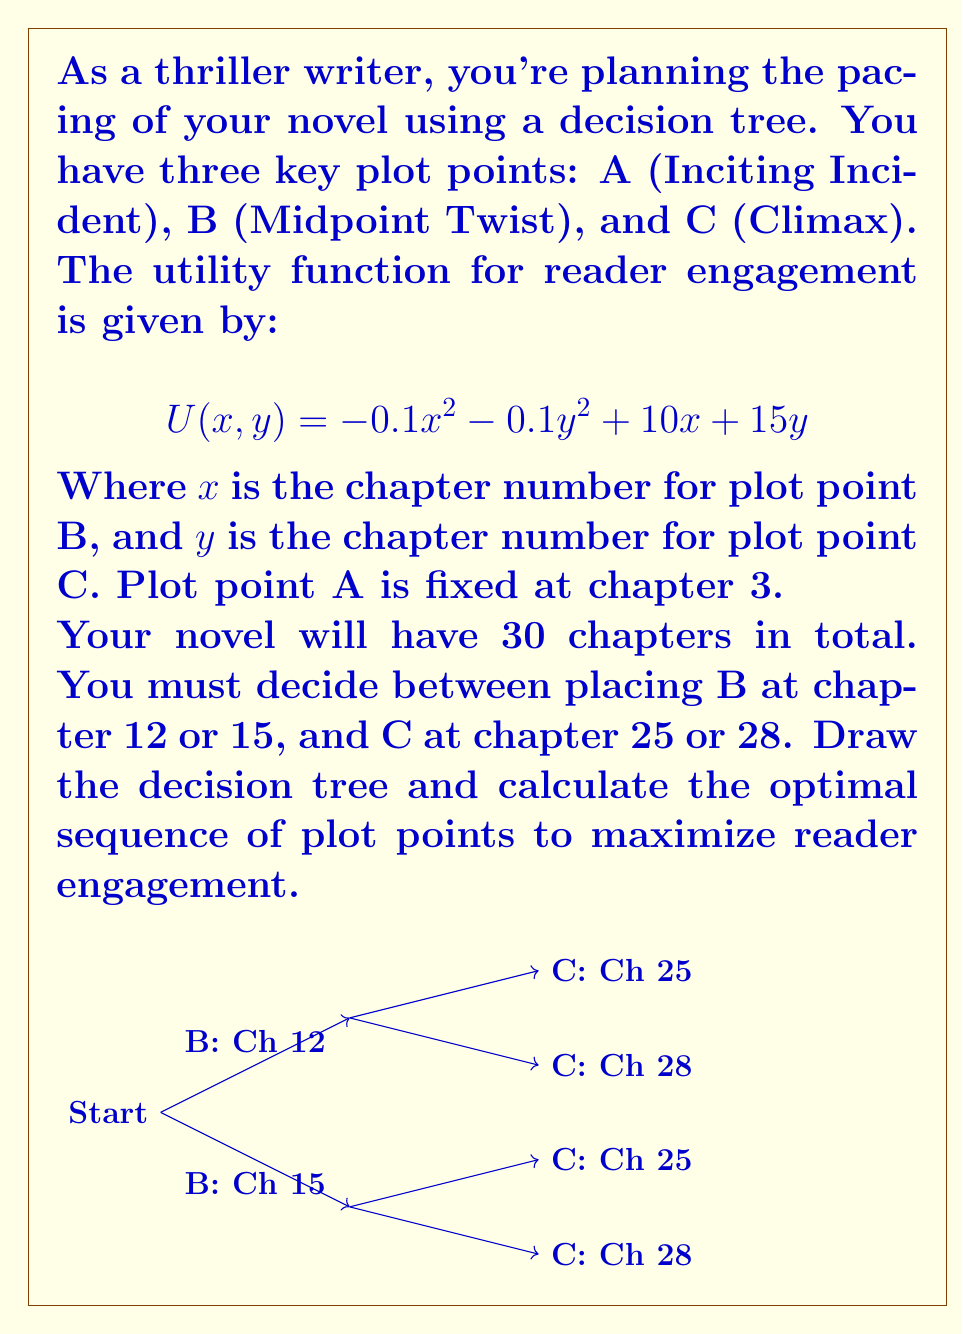What is the answer to this math problem? Let's approach this step-by-step:

1) We need to calculate the utility for each combination of B and C:

   a) B at 12, C at 25: 
      $$U(12, 25) = -0.1(12^2) - 0.1(25^2) + 10(12) + 15(25) = 446.5$$

   b) B at 12, C at 28:
      $$U(12, 28) = -0.1(12^2) - 0.1(28^2) + 10(12) + 15(28) = 491.2$$

   c) B at 15, C at 25:
      $$U(15, 25) = -0.1(15^2) - 0.1(25^2) + 10(15) + 15(25) = 468.5$$

   d) B at 15, C at 28:
      $$U(15, 28) = -0.1(15^2) - 0.1(28^2) + 10(15) + 15(28) = 513.2$$

2) Now, let's fill in these values on our decision tree:

   [asy]
   unitsize(0.5cm);
   
   draw((0,0)--(6,3), arrow=Arrow(TeXHead));
   draw((0,0)--(6,-3), arrow=Arrow(TeXHead));
   draw((6,3)--(12,4.5), arrow=Arrow(TeXHead));
   draw((6,3)--(12,1.5), arrow=Arrow(TeXHead));
   draw((6,-3)--(12,-1.5), arrow=Arrow(TeXHead));
   draw((6,-3)--(12,-4.5), arrow=Arrow(TeXHead));
   
   label("Start", (0,0), W);
   label("B: Ch 12", (6,3), N);
   label("B: Ch 15", (6,-3), S);
   label("C: Ch 25 (446.5)", (12,4.5), E);
   label("C: Ch 28 (491.2)", (12,1.5), E);
   label("C: Ch 25 (468.5)", (12,-1.5), E);
   label("C: Ch 28 (513.2)", (12,-4.5), E);
   [/asy]

3) To find the optimal path, we work backwards:

   - If B is at chapter 12, the best option for C is chapter 28 (491.2 > 446.5)
   - If B is at chapter 15, the best option for C is chapter 28 (513.2 > 468.5)

4) Now we compare the best options for B:

   - B at 12 leads to a maximum utility of 491.2
   - B at 15 leads to a maximum utility of 513.2

5) Therefore, the optimal path is:
   A at chapter 3, B at chapter 15, and C at chapter 28, resulting in a utility of 513.2.
Answer: A: Ch 3, B: Ch 15, C: Ch 28 